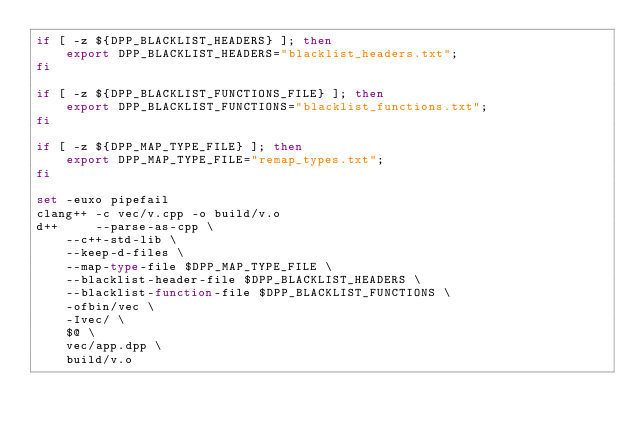<code> <loc_0><loc_0><loc_500><loc_500><_Bash_>if [ -z ${DPP_BLACKLIST_HEADERS} ]; then
	export DPP_BLACKLIST_HEADERS="blacklist_headers.txt";
fi

if [ -z ${DPP_BLACKLIST_FUNCTIONS_FILE} ]; then
	export DPP_BLACKLIST_FUNCTIONS="blacklist_functions.txt";
fi

if [ -z ${DPP_MAP_TYPE_FILE} ]; then
	export DPP_MAP_TYPE_FILE="remap_types.txt";
fi

set -euxo pipefail
clang++ -c vec/v.cpp -o build/v.o
d++ 	--parse-as-cpp \
	--c++-std-lib \
	--keep-d-files \
	--map-type-file $DPP_MAP_TYPE_FILE \
	--blacklist-header-file $DPP_BLACKLIST_HEADERS \
	--blacklist-function-file $DPP_BLACKLIST_FUNCTIONS \
	-ofbin/vec \
	-Ivec/ \
    $@ \
	vec/app.dpp \
	build/v.o

</code> 